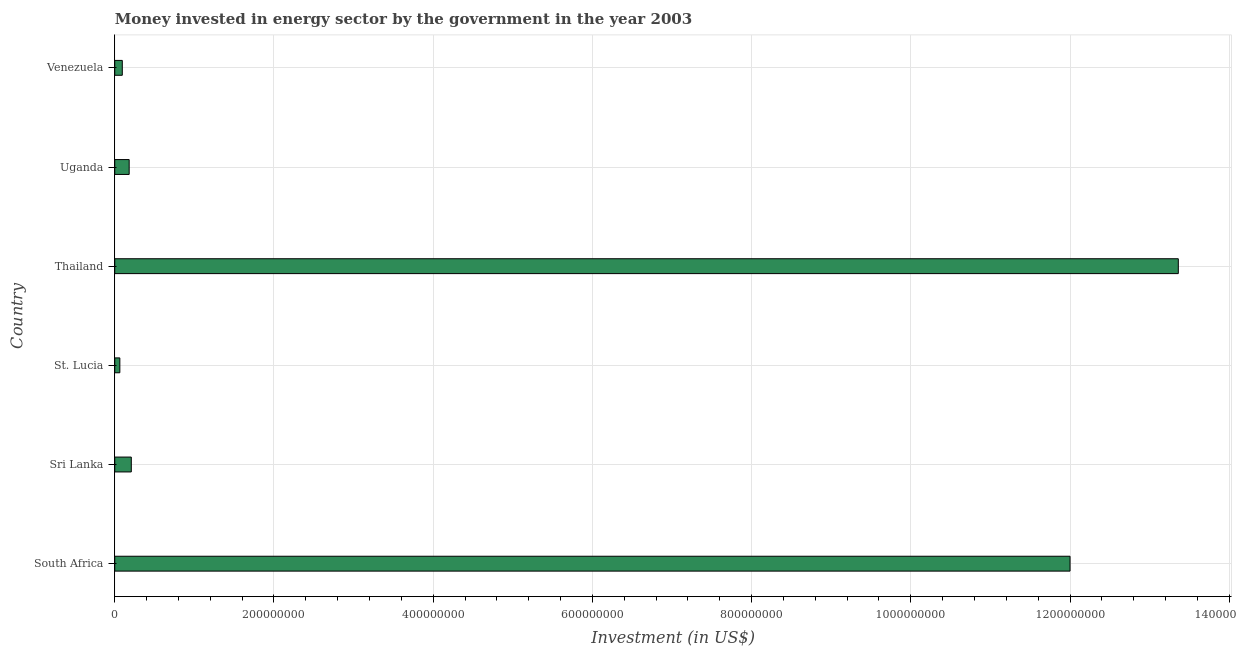Does the graph contain grids?
Your response must be concise. Yes. What is the title of the graph?
Keep it short and to the point. Money invested in energy sector by the government in the year 2003. What is the label or title of the X-axis?
Give a very brief answer. Investment (in US$). What is the investment in energy in Uganda?
Your answer should be compact. 1.81e+07. Across all countries, what is the maximum investment in energy?
Provide a succinct answer. 1.34e+09. Across all countries, what is the minimum investment in energy?
Provide a short and direct response. 6.40e+06. In which country was the investment in energy maximum?
Provide a succinct answer. Thailand. In which country was the investment in energy minimum?
Offer a terse response. St. Lucia. What is the sum of the investment in energy?
Keep it short and to the point. 2.59e+09. What is the difference between the investment in energy in Sri Lanka and Uganda?
Ensure brevity in your answer.  2.68e+06. What is the average investment in energy per country?
Make the answer very short. 4.32e+08. What is the median investment in energy?
Offer a very short reply. 1.94e+07. In how many countries, is the investment in energy greater than 80000000 US$?
Give a very brief answer. 2. What is the ratio of the investment in energy in Sri Lanka to that in Thailand?
Your response must be concise. 0.02. Is the difference between the investment in energy in St. Lucia and Thailand greater than the difference between any two countries?
Offer a terse response. Yes. What is the difference between the highest and the second highest investment in energy?
Keep it short and to the point. 1.36e+08. What is the difference between the highest and the lowest investment in energy?
Offer a very short reply. 1.33e+09. In how many countries, is the investment in energy greater than the average investment in energy taken over all countries?
Give a very brief answer. 2. How many bars are there?
Make the answer very short. 6. Are all the bars in the graph horizontal?
Give a very brief answer. Yes. How many countries are there in the graph?
Provide a succinct answer. 6. What is the difference between two consecutive major ticks on the X-axis?
Your answer should be compact. 2.00e+08. Are the values on the major ticks of X-axis written in scientific E-notation?
Keep it short and to the point. No. What is the Investment (in US$) of South Africa?
Your response must be concise. 1.20e+09. What is the Investment (in US$) of Sri Lanka?
Ensure brevity in your answer.  2.08e+07. What is the Investment (in US$) of St. Lucia?
Provide a succinct answer. 6.40e+06. What is the Investment (in US$) of Thailand?
Your answer should be compact. 1.34e+09. What is the Investment (in US$) in Uganda?
Give a very brief answer. 1.81e+07. What is the Investment (in US$) in Venezuela?
Offer a very short reply. 9.47e+06. What is the difference between the Investment (in US$) in South Africa and Sri Lanka?
Make the answer very short. 1.18e+09. What is the difference between the Investment (in US$) in South Africa and St. Lucia?
Offer a very short reply. 1.19e+09. What is the difference between the Investment (in US$) in South Africa and Thailand?
Provide a succinct answer. -1.36e+08. What is the difference between the Investment (in US$) in South Africa and Uganda?
Keep it short and to the point. 1.18e+09. What is the difference between the Investment (in US$) in South Africa and Venezuela?
Your answer should be compact. 1.19e+09. What is the difference between the Investment (in US$) in Sri Lanka and St. Lucia?
Your answer should be very brief. 1.44e+07. What is the difference between the Investment (in US$) in Sri Lanka and Thailand?
Make the answer very short. -1.32e+09. What is the difference between the Investment (in US$) in Sri Lanka and Uganda?
Ensure brevity in your answer.  2.68e+06. What is the difference between the Investment (in US$) in Sri Lanka and Venezuela?
Your answer should be compact. 1.13e+07. What is the difference between the Investment (in US$) in St. Lucia and Thailand?
Your answer should be very brief. -1.33e+09. What is the difference between the Investment (in US$) in St. Lucia and Uganda?
Offer a terse response. -1.17e+07. What is the difference between the Investment (in US$) in St. Lucia and Venezuela?
Offer a very short reply. -3.07e+06. What is the difference between the Investment (in US$) in Thailand and Uganda?
Offer a terse response. 1.32e+09. What is the difference between the Investment (in US$) in Thailand and Venezuela?
Provide a succinct answer. 1.33e+09. What is the difference between the Investment (in US$) in Uganda and Venezuela?
Provide a succinct answer. 8.63e+06. What is the ratio of the Investment (in US$) in South Africa to that in Sri Lanka?
Keep it short and to the point. 57.75. What is the ratio of the Investment (in US$) in South Africa to that in St. Lucia?
Provide a short and direct response. 187.5. What is the ratio of the Investment (in US$) in South Africa to that in Thailand?
Offer a terse response. 0.9. What is the ratio of the Investment (in US$) in South Africa to that in Uganda?
Make the answer very short. 66.3. What is the ratio of the Investment (in US$) in South Africa to that in Venezuela?
Your answer should be very brief. 126.72. What is the ratio of the Investment (in US$) in Sri Lanka to that in St. Lucia?
Provide a short and direct response. 3.25. What is the ratio of the Investment (in US$) in Sri Lanka to that in Thailand?
Your answer should be very brief. 0.02. What is the ratio of the Investment (in US$) in Sri Lanka to that in Uganda?
Provide a succinct answer. 1.15. What is the ratio of the Investment (in US$) in Sri Lanka to that in Venezuela?
Ensure brevity in your answer.  2.19. What is the ratio of the Investment (in US$) in St. Lucia to that in Thailand?
Keep it short and to the point. 0.01. What is the ratio of the Investment (in US$) in St. Lucia to that in Uganda?
Provide a succinct answer. 0.35. What is the ratio of the Investment (in US$) in St. Lucia to that in Venezuela?
Ensure brevity in your answer.  0.68. What is the ratio of the Investment (in US$) in Thailand to that in Uganda?
Offer a terse response. 73.81. What is the ratio of the Investment (in US$) in Thailand to that in Venezuela?
Provide a succinct answer. 141.08. What is the ratio of the Investment (in US$) in Uganda to that in Venezuela?
Ensure brevity in your answer.  1.91. 